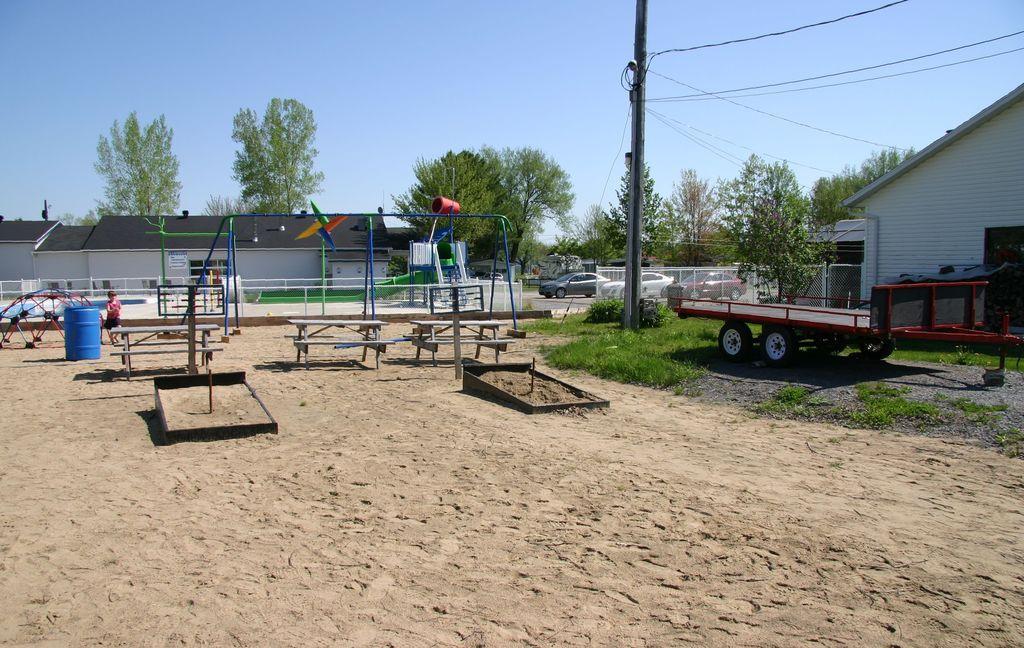In one or two sentences, can you explain what this image depicts? This is an outside view. On the left side, I can see some playground equipment on the ground and also there are few benches and a drum. There is a person walking on the ground. On the right side there is a truck. In the background there are some houses, trees and I can see few vehicles on the road. In the middle of the image there is a pole along with the wires. At the top of the image I can see the sky. 